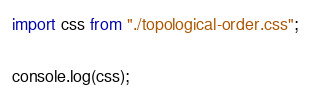Convert code to text. <code><loc_0><loc_0><loc_500><loc_500><_JavaScript_>import css from "./topological-order.css";

console.log(css);
</code> 